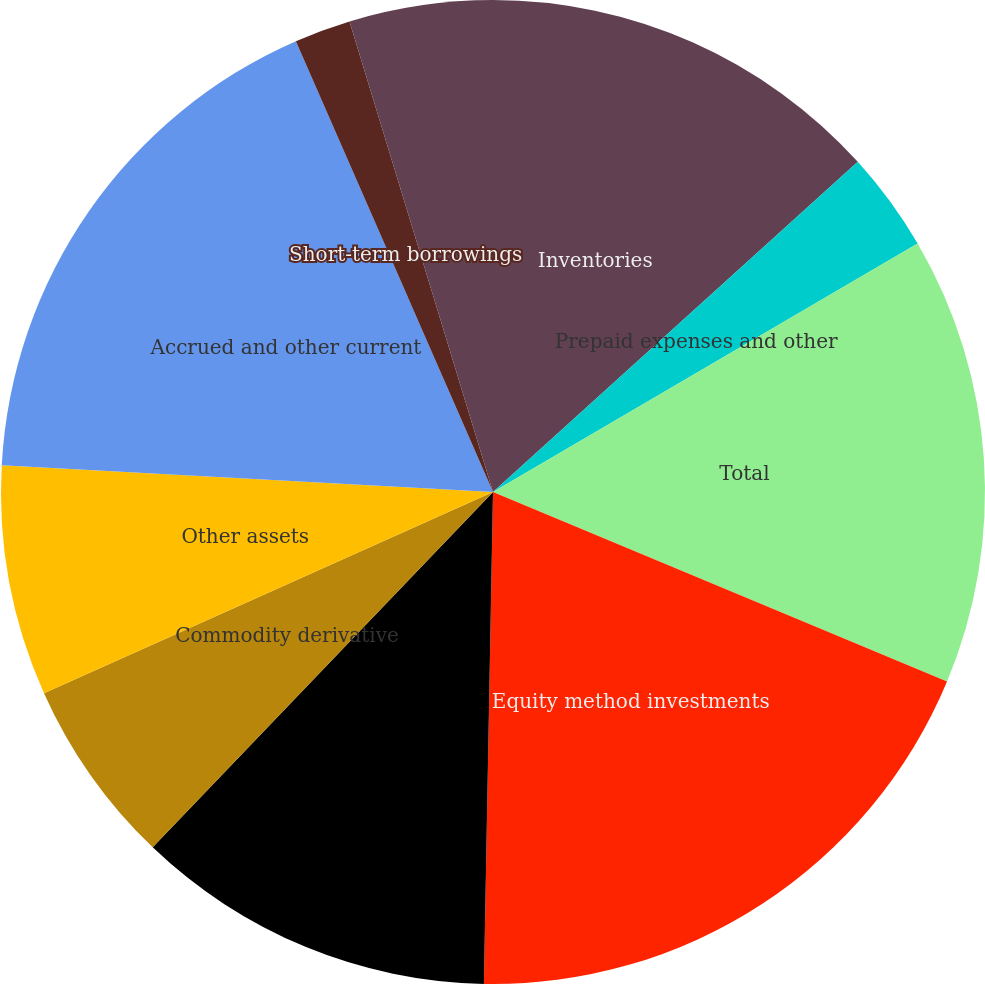Convert chart to OTSL. <chart><loc_0><loc_0><loc_500><loc_500><pie_chart><fcel>Inventories<fcel>Prepaid expenses and other<fcel>Total<fcel>Equity method investments<fcel>Mutual fund investments<fcel>Commodity derivative<fcel>Other assets<fcel>Accrued and other current<fcel>Short-term borrowings<fcel>Asset retirement obligations<nl><fcel>13.29%<fcel>3.28%<fcel>14.72%<fcel>19.0%<fcel>11.86%<fcel>6.14%<fcel>7.57%<fcel>17.57%<fcel>1.85%<fcel>4.71%<nl></chart> 